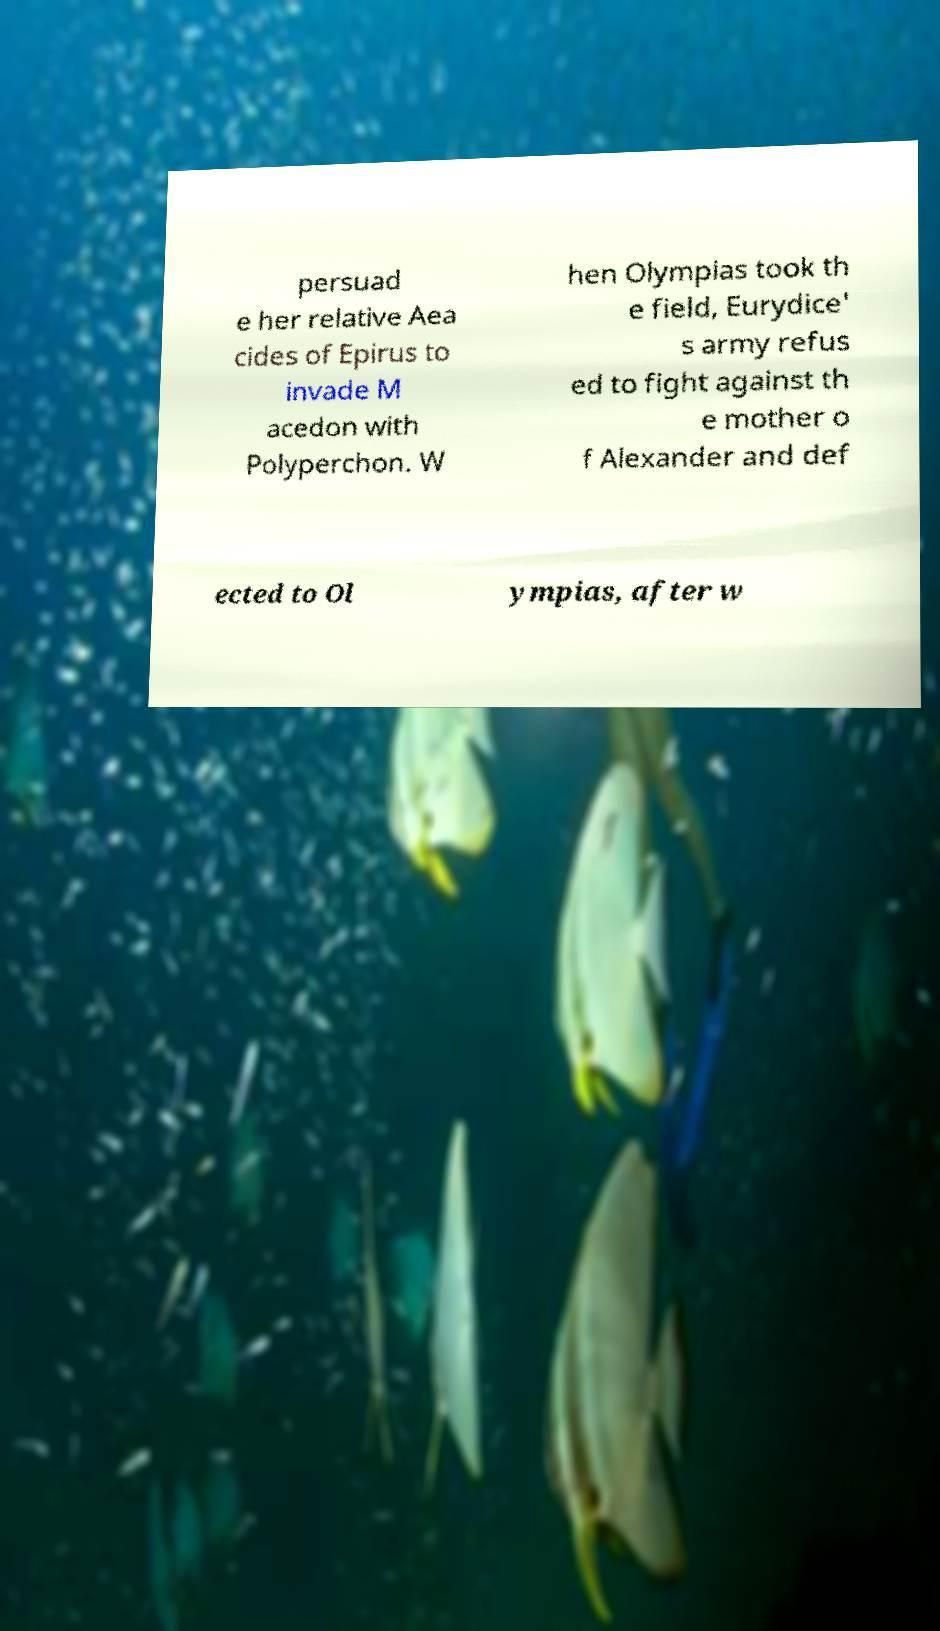Can you read and provide the text displayed in the image?This photo seems to have some interesting text. Can you extract and type it out for me? persuad e her relative Aea cides of Epirus to invade M acedon with Polyperchon. W hen Olympias took th e field, Eurydice' s army refus ed to fight against th e mother o f Alexander and def ected to Ol ympias, after w 